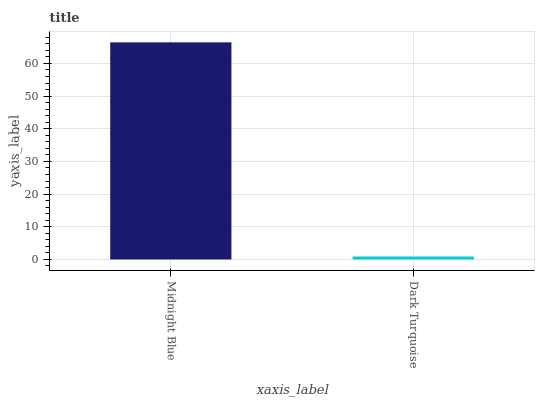Is Dark Turquoise the minimum?
Answer yes or no. Yes. Is Midnight Blue the maximum?
Answer yes or no. Yes. Is Dark Turquoise the maximum?
Answer yes or no. No. Is Midnight Blue greater than Dark Turquoise?
Answer yes or no. Yes. Is Dark Turquoise less than Midnight Blue?
Answer yes or no. Yes. Is Dark Turquoise greater than Midnight Blue?
Answer yes or no. No. Is Midnight Blue less than Dark Turquoise?
Answer yes or no. No. Is Midnight Blue the high median?
Answer yes or no. Yes. Is Dark Turquoise the low median?
Answer yes or no. Yes. Is Dark Turquoise the high median?
Answer yes or no. No. Is Midnight Blue the low median?
Answer yes or no. No. 